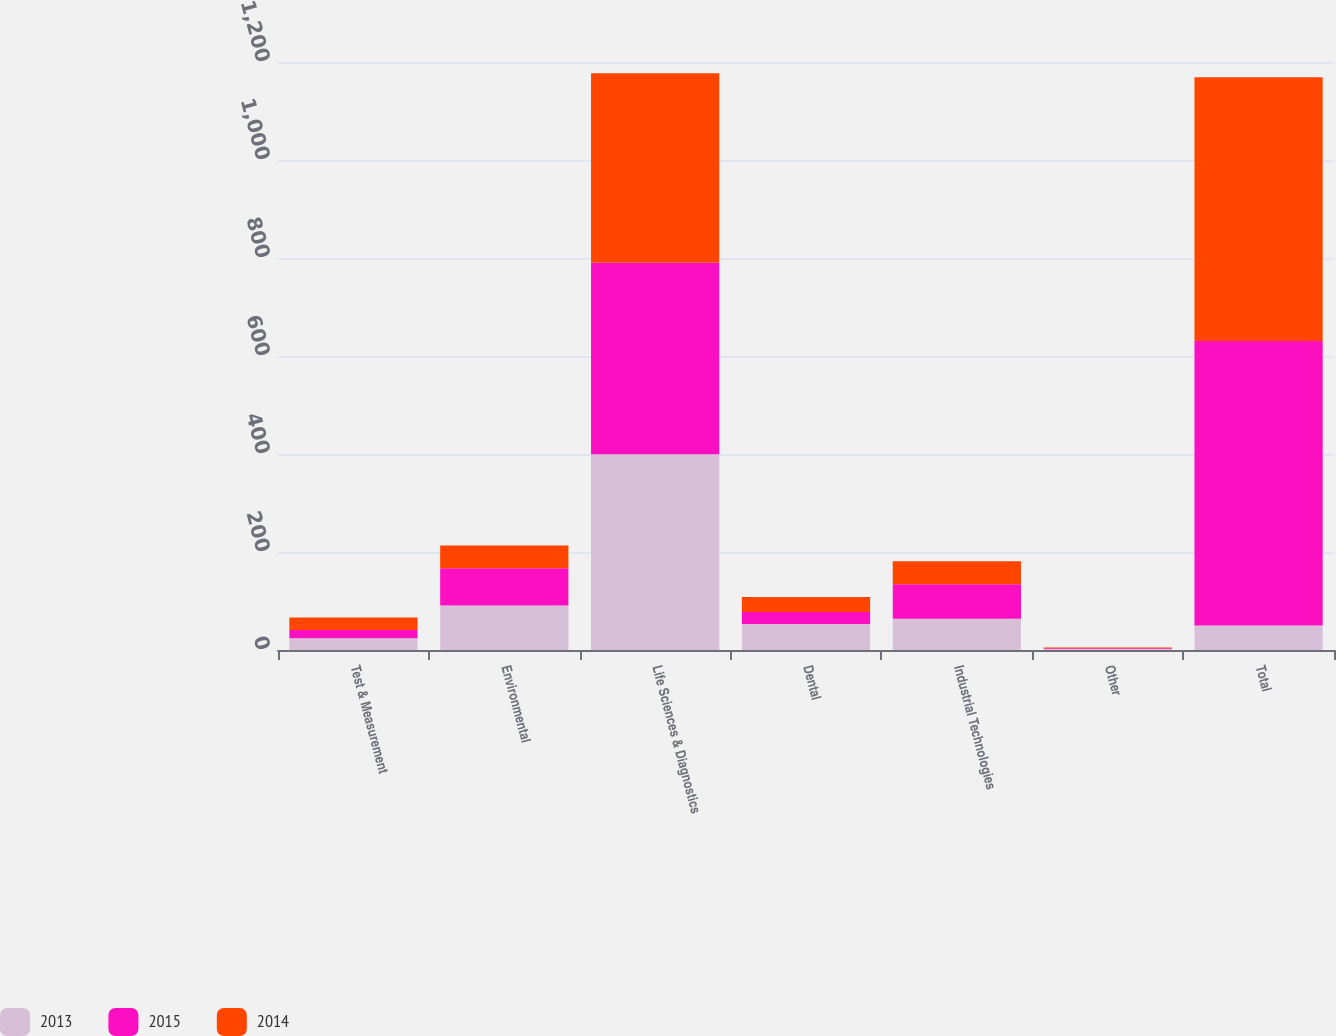Convert chart. <chart><loc_0><loc_0><loc_500><loc_500><stacked_bar_chart><ecel><fcel>Test & Measurement<fcel>Environmental<fcel>Life Sciences & Diagnostics<fcel>Dental<fcel>Industrial Technologies<fcel>Other<fcel>Total<nl><fcel>2013<fcel>23.8<fcel>90.8<fcel>399.4<fcel>53.3<fcel>63.6<fcel>2.1<fcel>50.2<nl><fcel>2015<fcel>17<fcel>76.1<fcel>391.1<fcel>24.4<fcel>70.6<fcel>1.4<fcel>580.6<nl><fcel>2014<fcel>25.4<fcel>46.5<fcel>386.7<fcel>30.7<fcel>47.1<fcel>1.7<fcel>538.1<nl></chart> 